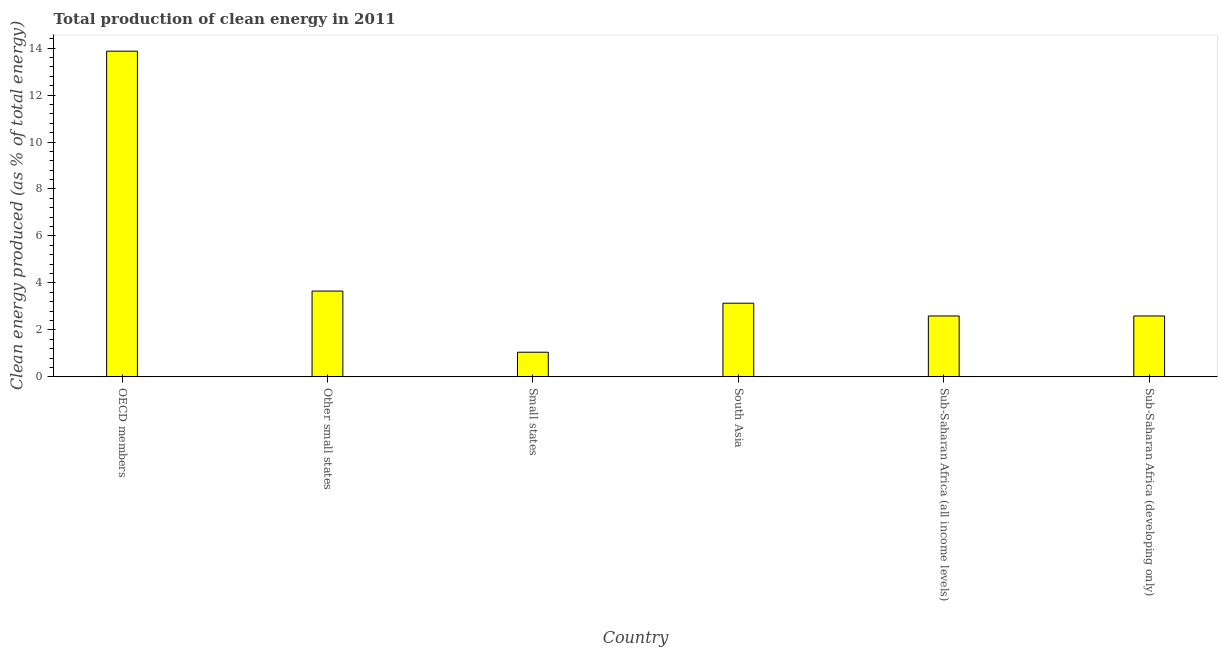Does the graph contain grids?
Offer a very short reply. No. What is the title of the graph?
Ensure brevity in your answer.  Total production of clean energy in 2011. What is the label or title of the X-axis?
Offer a very short reply. Country. What is the label or title of the Y-axis?
Provide a short and direct response. Clean energy produced (as % of total energy). What is the production of clean energy in South Asia?
Provide a succinct answer. 3.14. Across all countries, what is the maximum production of clean energy?
Offer a very short reply. 13.87. Across all countries, what is the minimum production of clean energy?
Make the answer very short. 1.05. In which country was the production of clean energy maximum?
Make the answer very short. OECD members. In which country was the production of clean energy minimum?
Provide a succinct answer. Small states. What is the sum of the production of clean energy?
Your response must be concise. 26.89. What is the difference between the production of clean energy in South Asia and Sub-Saharan Africa (all income levels)?
Provide a succinct answer. 0.54. What is the average production of clean energy per country?
Ensure brevity in your answer.  4.48. What is the median production of clean energy?
Ensure brevity in your answer.  2.87. What is the ratio of the production of clean energy in OECD members to that in Sub-Saharan Africa (all income levels)?
Provide a succinct answer. 5.35. Is the production of clean energy in Small states less than that in South Asia?
Keep it short and to the point. Yes. Is the difference between the production of clean energy in Other small states and South Asia greater than the difference between any two countries?
Give a very brief answer. No. What is the difference between the highest and the second highest production of clean energy?
Provide a short and direct response. 10.21. What is the difference between the highest and the lowest production of clean energy?
Your response must be concise. 12.82. In how many countries, is the production of clean energy greater than the average production of clean energy taken over all countries?
Keep it short and to the point. 1. How many bars are there?
Your answer should be compact. 6. How many countries are there in the graph?
Offer a very short reply. 6. What is the difference between two consecutive major ticks on the Y-axis?
Give a very brief answer. 2. Are the values on the major ticks of Y-axis written in scientific E-notation?
Your answer should be compact. No. What is the Clean energy produced (as % of total energy) in OECD members?
Your answer should be very brief. 13.87. What is the Clean energy produced (as % of total energy) of Other small states?
Provide a succinct answer. 3.65. What is the Clean energy produced (as % of total energy) of Small states?
Keep it short and to the point. 1.05. What is the Clean energy produced (as % of total energy) in South Asia?
Offer a terse response. 3.14. What is the Clean energy produced (as % of total energy) of Sub-Saharan Africa (all income levels)?
Offer a very short reply. 2.59. What is the Clean energy produced (as % of total energy) of Sub-Saharan Africa (developing only)?
Offer a terse response. 2.59. What is the difference between the Clean energy produced (as % of total energy) in OECD members and Other small states?
Your response must be concise. 10.22. What is the difference between the Clean energy produced (as % of total energy) in OECD members and Small states?
Offer a terse response. 12.82. What is the difference between the Clean energy produced (as % of total energy) in OECD members and South Asia?
Keep it short and to the point. 10.73. What is the difference between the Clean energy produced (as % of total energy) in OECD members and Sub-Saharan Africa (all income levels)?
Keep it short and to the point. 11.28. What is the difference between the Clean energy produced (as % of total energy) in OECD members and Sub-Saharan Africa (developing only)?
Your response must be concise. 11.28. What is the difference between the Clean energy produced (as % of total energy) in Other small states and Small states?
Give a very brief answer. 2.6. What is the difference between the Clean energy produced (as % of total energy) in Other small states and South Asia?
Offer a very short reply. 0.52. What is the difference between the Clean energy produced (as % of total energy) in Other small states and Sub-Saharan Africa (all income levels)?
Give a very brief answer. 1.06. What is the difference between the Clean energy produced (as % of total energy) in Other small states and Sub-Saharan Africa (developing only)?
Provide a succinct answer. 1.06. What is the difference between the Clean energy produced (as % of total energy) in Small states and South Asia?
Give a very brief answer. -2.09. What is the difference between the Clean energy produced (as % of total energy) in Small states and Sub-Saharan Africa (all income levels)?
Make the answer very short. -1.54. What is the difference between the Clean energy produced (as % of total energy) in Small states and Sub-Saharan Africa (developing only)?
Your answer should be very brief. -1.54. What is the difference between the Clean energy produced (as % of total energy) in South Asia and Sub-Saharan Africa (all income levels)?
Keep it short and to the point. 0.54. What is the difference between the Clean energy produced (as % of total energy) in South Asia and Sub-Saharan Africa (developing only)?
Offer a terse response. 0.54. What is the ratio of the Clean energy produced (as % of total energy) in OECD members to that in Other small states?
Provide a succinct answer. 3.8. What is the ratio of the Clean energy produced (as % of total energy) in OECD members to that in Small states?
Give a very brief answer. 13.22. What is the ratio of the Clean energy produced (as % of total energy) in OECD members to that in South Asia?
Offer a very short reply. 4.42. What is the ratio of the Clean energy produced (as % of total energy) in OECD members to that in Sub-Saharan Africa (all income levels)?
Your answer should be very brief. 5.35. What is the ratio of the Clean energy produced (as % of total energy) in OECD members to that in Sub-Saharan Africa (developing only)?
Ensure brevity in your answer.  5.35. What is the ratio of the Clean energy produced (as % of total energy) in Other small states to that in Small states?
Your answer should be compact. 3.48. What is the ratio of the Clean energy produced (as % of total energy) in Other small states to that in South Asia?
Ensure brevity in your answer.  1.16. What is the ratio of the Clean energy produced (as % of total energy) in Other small states to that in Sub-Saharan Africa (all income levels)?
Your response must be concise. 1.41. What is the ratio of the Clean energy produced (as % of total energy) in Other small states to that in Sub-Saharan Africa (developing only)?
Offer a very short reply. 1.41. What is the ratio of the Clean energy produced (as % of total energy) in Small states to that in South Asia?
Provide a short and direct response. 0.33. What is the ratio of the Clean energy produced (as % of total energy) in Small states to that in Sub-Saharan Africa (all income levels)?
Ensure brevity in your answer.  0.41. What is the ratio of the Clean energy produced (as % of total energy) in Small states to that in Sub-Saharan Africa (developing only)?
Ensure brevity in your answer.  0.41. What is the ratio of the Clean energy produced (as % of total energy) in South Asia to that in Sub-Saharan Africa (all income levels)?
Keep it short and to the point. 1.21. What is the ratio of the Clean energy produced (as % of total energy) in South Asia to that in Sub-Saharan Africa (developing only)?
Your answer should be very brief. 1.21. What is the ratio of the Clean energy produced (as % of total energy) in Sub-Saharan Africa (all income levels) to that in Sub-Saharan Africa (developing only)?
Your answer should be compact. 1. 